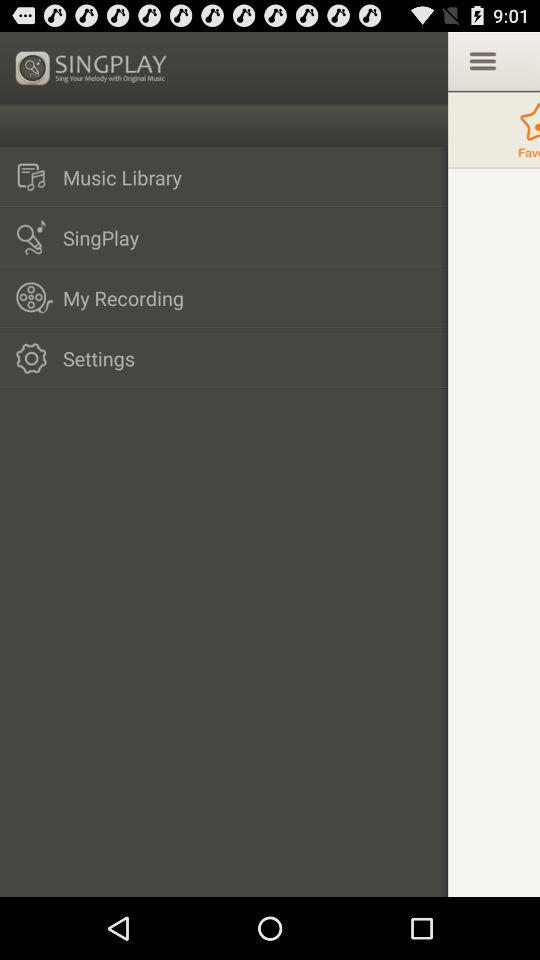What is the name of the application? The name of the application is "SINGPLAY". 